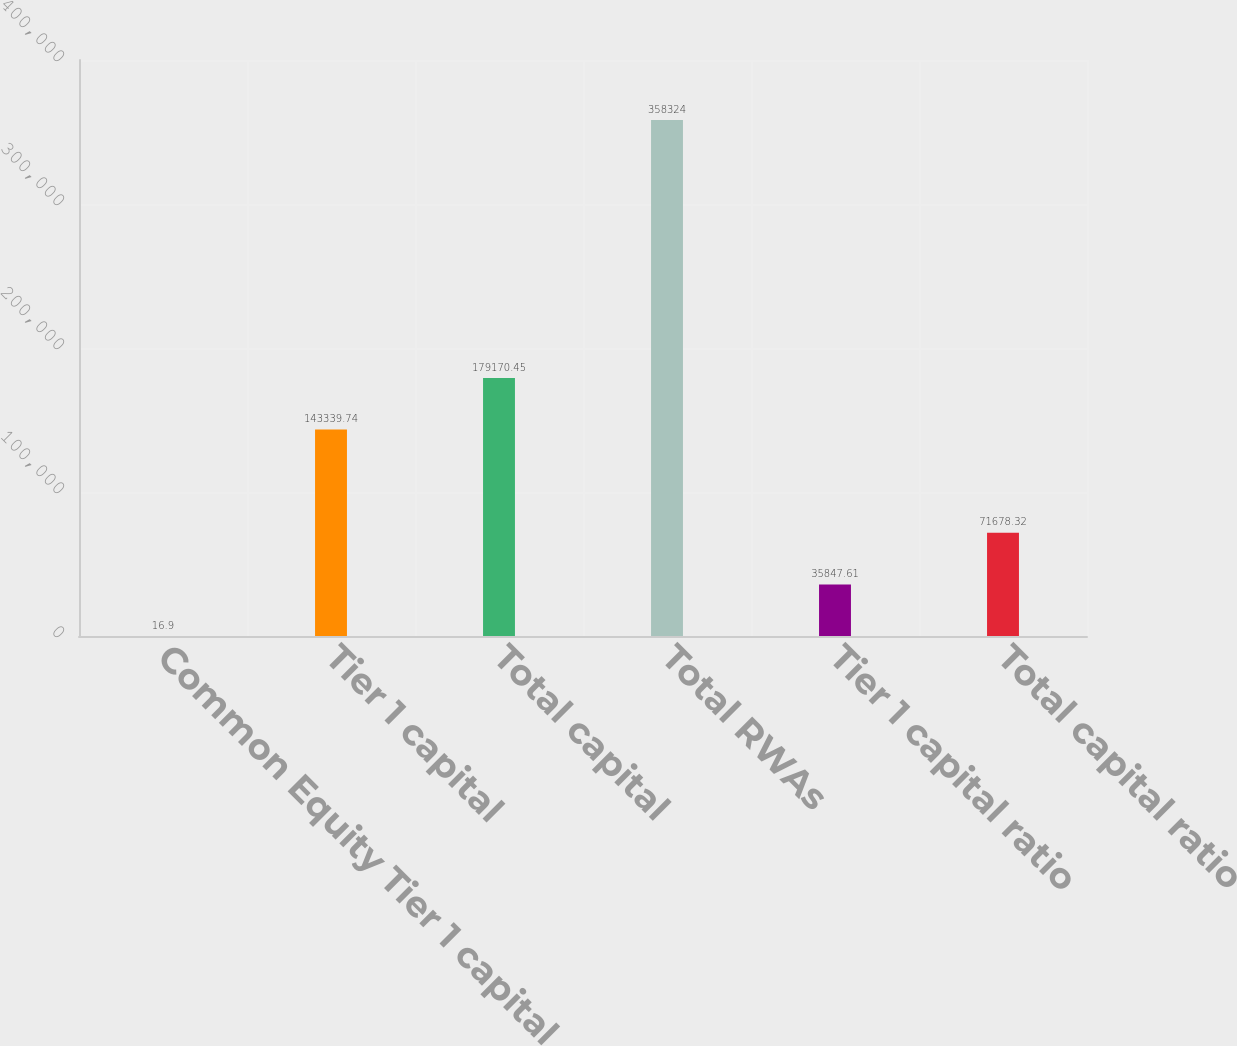Convert chart to OTSL. <chart><loc_0><loc_0><loc_500><loc_500><bar_chart><fcel>Common Equity Tier 1 capital<fcel>Tier 1 capital<fcel>Total capital<fcel>Total RWAs<fcel>Tier 1 capital ratio<fcel>Total capital ratio<nl><fcel>16.9<fcel>143340<fcel>179170<fcel>358324<fcel>35847.6<fcel>71678.3<nl></chart> 